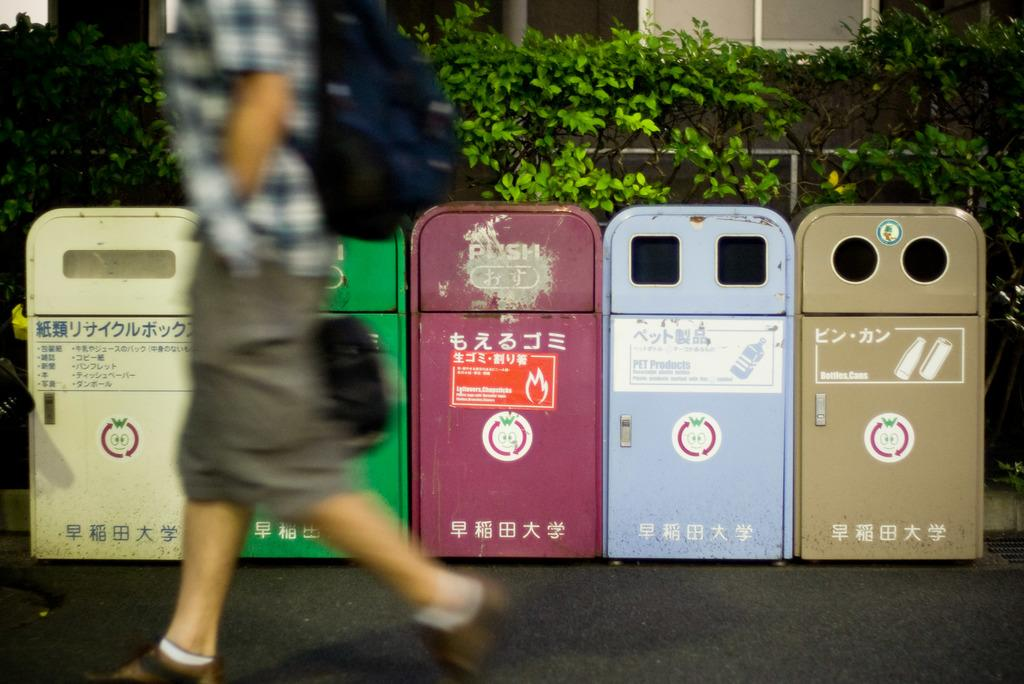<image>
Give a short and clear explanation of the subsequent image. A man walking by a bottles and cans receptacle and one for pet products. 